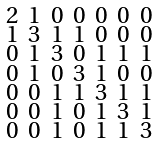Convert formula to latex. <formula><loc_0><loc_0><loc_500><loc_500>\begin{smallmatrix} 2 & 1 & 0 & 0 & 0 & 0 & 0 \\ 1 & 3 & 1 & 1 & 0 & 0 & 0 \\ 0 & 1 & 3 & 0 & 1 & 1 & 1 \\ 0 & 1 & 0 & 3 & 1 & 0 & 0 \\ 0 & 0 & 1 & 1 & 3 & 1 & 1 \\ 0 & 0 & 1 & 0 & 1 & 3 & 1 \\ 0 & 0 & 1 & 0 & 1 & 1 & 3 \end{smallmatrix}</formula> 